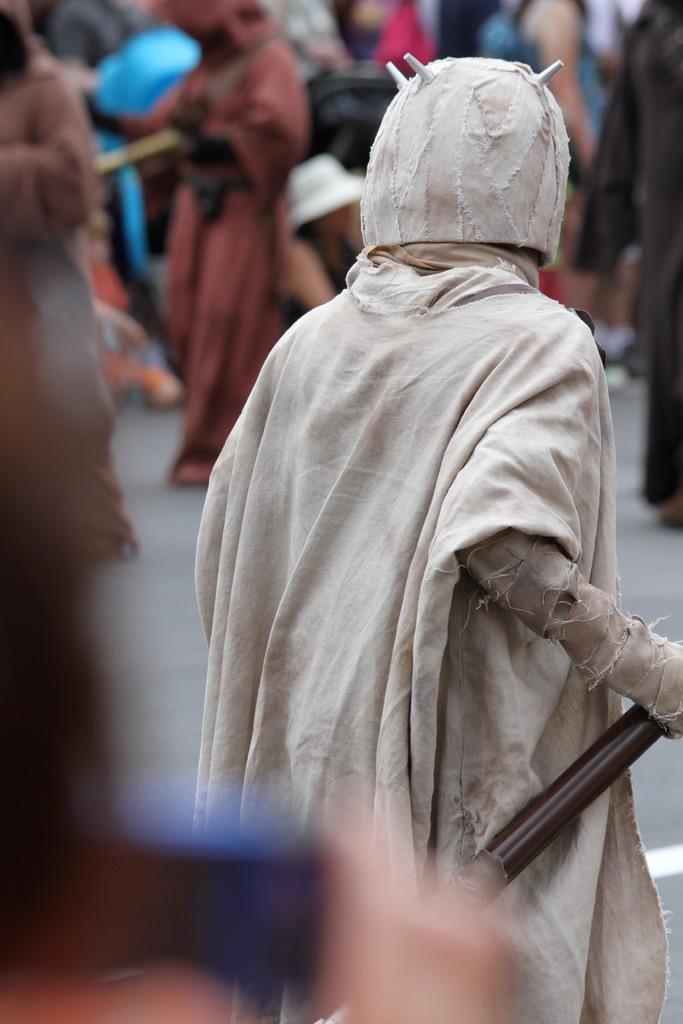Can you describe this image briefly? A person is holding an object, here people are standing. 